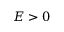Convert formula to latex. <formula><loc_0><loc_0><loc_500><loc_500>E > 0</formula> 